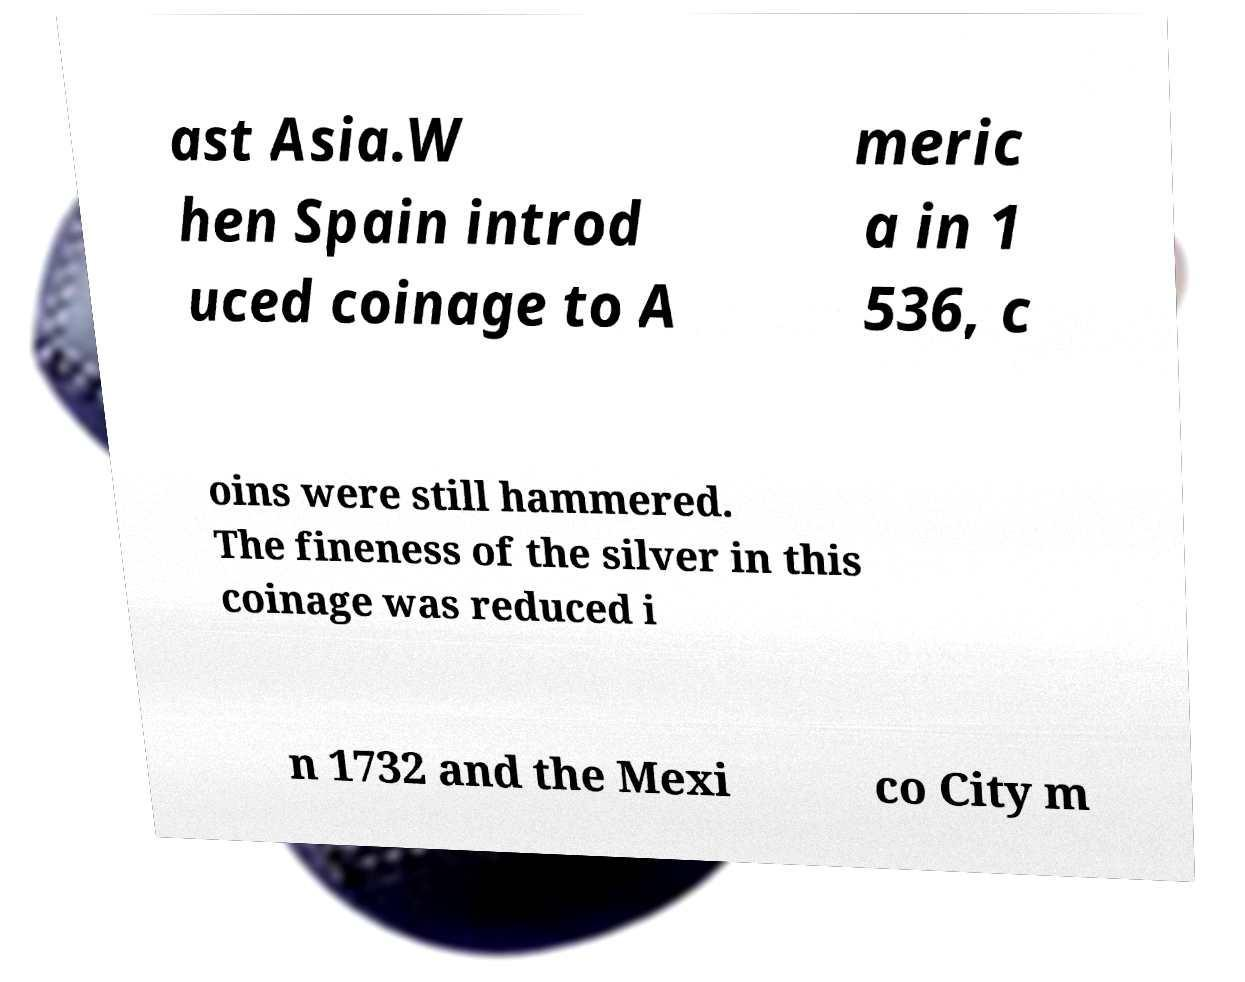Please identify and transcribe the text found in this image. ast Asia.W hen Spain introd uced coinage to A meric a in 1 536, c oins were still hammered. The fineness of the silver in this coinage was reduced i n 1732 and the Mexi co City m 